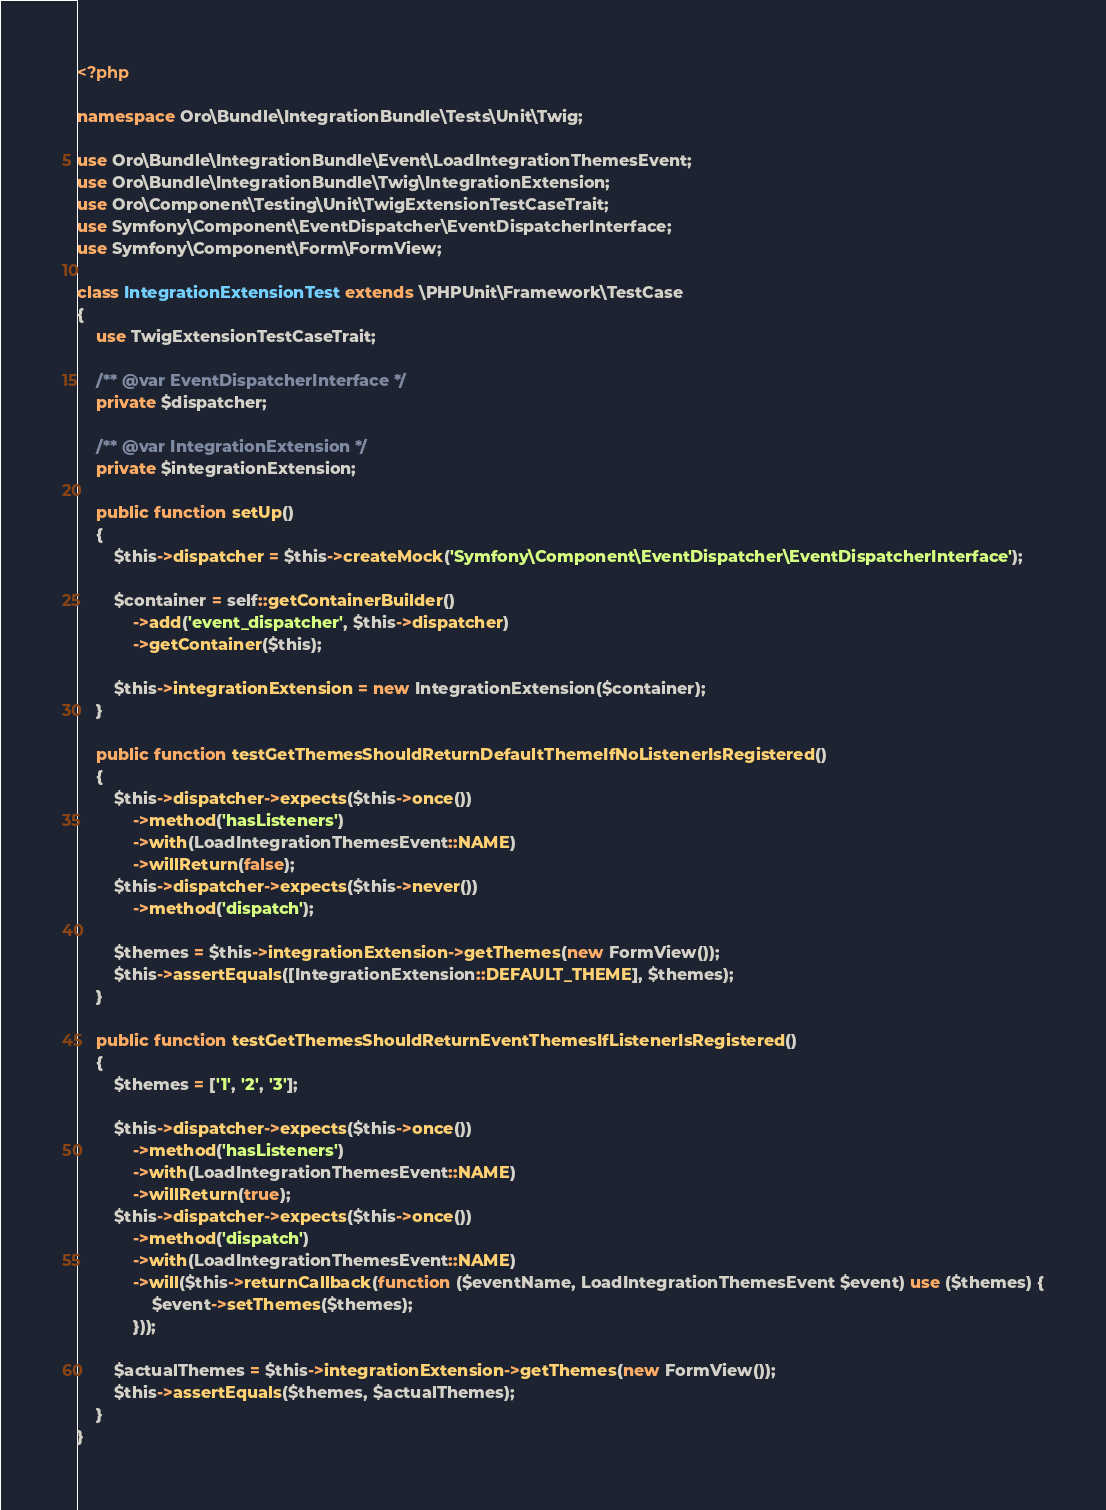<code> <loc_0><loc_0><loc_500><loc_500><_PHP_><?php

namespace Oro\Bundle\IntegrationBundle\Tests\Unit\Twig;

use Oro\Bundle\IntegrationBundle\Event\LoadIntegrationThemesEvent;
use Oro\Bundle\IntegrationBundle\Twig\IntegrationExtension;
use Oro\Component\Testing\Unit\TwigExtensionTestCaseTrait;
use Symfony\Component\EventDispatcher\EventDispatcherInterface;
use Symfony\Component\Form\FormView;

class IntegrationExtensionTest extends \PHPUnit\Framework\TestCase
{
    use TwigExtensionTestCaseTrait;

    /** @var EventDispatcherInterface */
    private $dispatcher;

    /** @var IntegrationExtension */
    private $integrationExtension;

    public function setUp()
    {
        $this->dispatcher = $this->createMock('Symfony\Component\EventDispatcher\EventDispatcherInterface');

        $container = self::getContainerBuilder()
            ->add('event_dispatcher', $this->dispatcher)
            ->getContainer($this);

        $this->integrationExtension = new IntegrationExtension($container);
    }

    public function testGetThemesShouldReturnDefaultThemeIfNoListenerIsRegistered()
    {
        $this->dispatcher->expects($this->once())
            ->method('hasListeners')
            ->with(LoadIntegrationThemesEvent::NAME)
            ->willReturn(false);
        $this->dispatcher->expects($this->never())
            ->method('dispatch');

        $themes = $this->integrationExtension->getThemes(new FormView());
        $this->assertEquals([IntegrationExtension::DEFAULT_THEME], $themes);
    }

    public function testGetThemesShouldReturnEventThemesIfListenerIsRegistered()
    {
        $themes = ['1', '2', '3'];

        $this->dispatcher->expects($this->once())
            ->method('hasListeners')
            ->with(LoadIntegrationThemesEvent::NAME)
            ->willReturn(true);
        $this->dispatcher->expects($this->once())
            ->method('dispatch')
            ->with(LoadIntegrationThemesEvent::NAME)
            ->will($this->returnCallback(function ($eventName, LoadIntegrationThemesEvent $event) use ($themes) {
                $event->setThemes($themes);
            }));

        $actualThemes = $this->integrationExtension->getThemes(new FormView());
        $this->assertEquals($themes, $actualThemes);
    }
}
</code> 